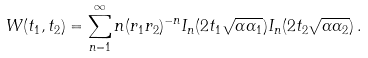Convert formula to latex. <formula><loc_0><loc_0><loc_500><loc_500>W ( t _ { 1 } , t _ { 2 } ) = \sum _ { n = 1 } ^ { \infty } n ( r _ { 1 } r _ { 2 } ) ^ { - n } I _ { n } ( 2 t _ { 1 } \sqrt { \alpha \alpha _ { 1 } } ) I _ { n } ( 2 t _ { 2 } \sqrt { \alpha \alpha _ { 2 } } ) \, .</formula> 